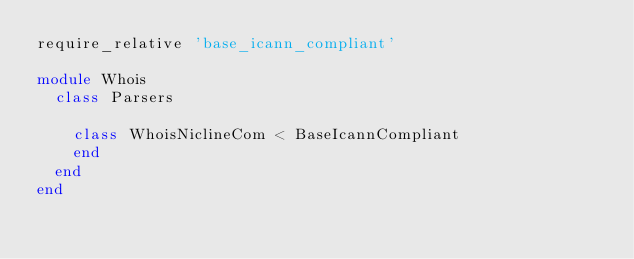<code> <loc_0><loc_0><loc_500><loc_500><_Ruby_>require_relative 'base_icann_compliant'

module Whois
  class Parsers

    class WhoisNiclineCom < BaseIcannCompliant
    end
  end
end</code> 